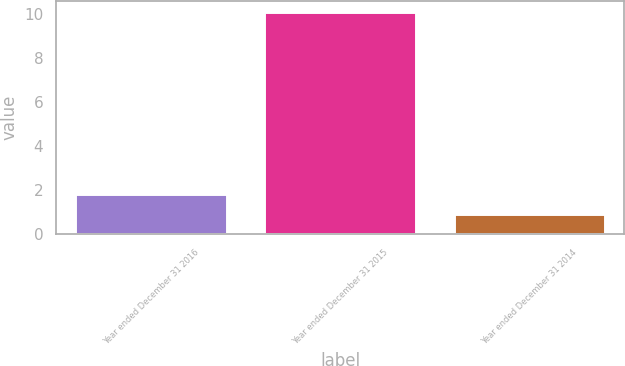<chart> <loc_0><loc_0><loc_500><loc_500><bar_chart><fcel>Year ended December 31 2016<fcel>Year ended December 31 2015<fcel>Year ended December 31 2014<nl><fcel>1.82<fcel>10.1<fcel>0.9<nl></chart> 